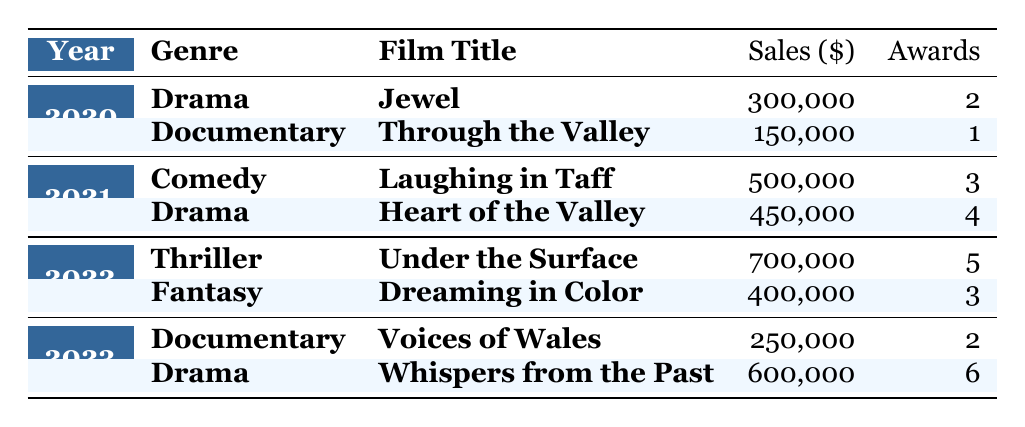What film won the most awards in 2021? In 2021, there are two films listed: "Laughing in Taff" with 3 awards and "Heart of the Valley" with 4 awards. The film with the most awards is "Heart of the Valley."
Answer: Heart of the Valley What are the total sales of Kieran Evans' films in 2023? In 2023, there are two films listed: "Voices of Wales" with sales of 250,000 and "Whispers from the Past" with sales of 600,000. The total sales are 250,000 + 600,000 = 850,000.
Answer: 850,000 Did Kieran Evans release a Fantasy film in 2020? According to the table, there are no films listed under the Fantasy genre for 2020. Therefore, the answer is no.
Answer: No Which genre had the highest sales in 2022? The two genres listed in 2022 are Thriller with "Under the Surface" at 700,000 and Fantasy with "Dreaming in Color" at 400,000. The highest sales are from the Thriller genre, totaling 700,000.
Answer: Thriller What is the average sales of Kieran Evans' Drama films? The Drama films listed are "Jewel" (300,000), "Heart of the Valley" (450,000), and "Whispers from the Past" (600,000). Summing these gives 300,000 + 450,000 + 600,000 = 1,350,000. There are three Drama films, so the average sales are 1,350,000 / 3 = 450,000.
Answer: 450,000 What was the genre of the film with the highest sales overall? The film with the highest sales is "Under the Surface" with sales of 700,000. The genre of this film is Thriller.
Answer: Thriller How many different genres did Kieran Evans cover in 2021? In 2021, there are two genres: Comedy ("Laughing in Taff") and Drama ("Heart of the Valley"). Therefore, Kieran Evans covered 2 genres that year.
Answer: 2 Which film sold the least in 2020? The films in 2020 are "Jewel" with 300,000 and "Through the Valley" with 150,000. "Through the Valley" has the lowest sales at 150,000.
Answer: Through the Valley 